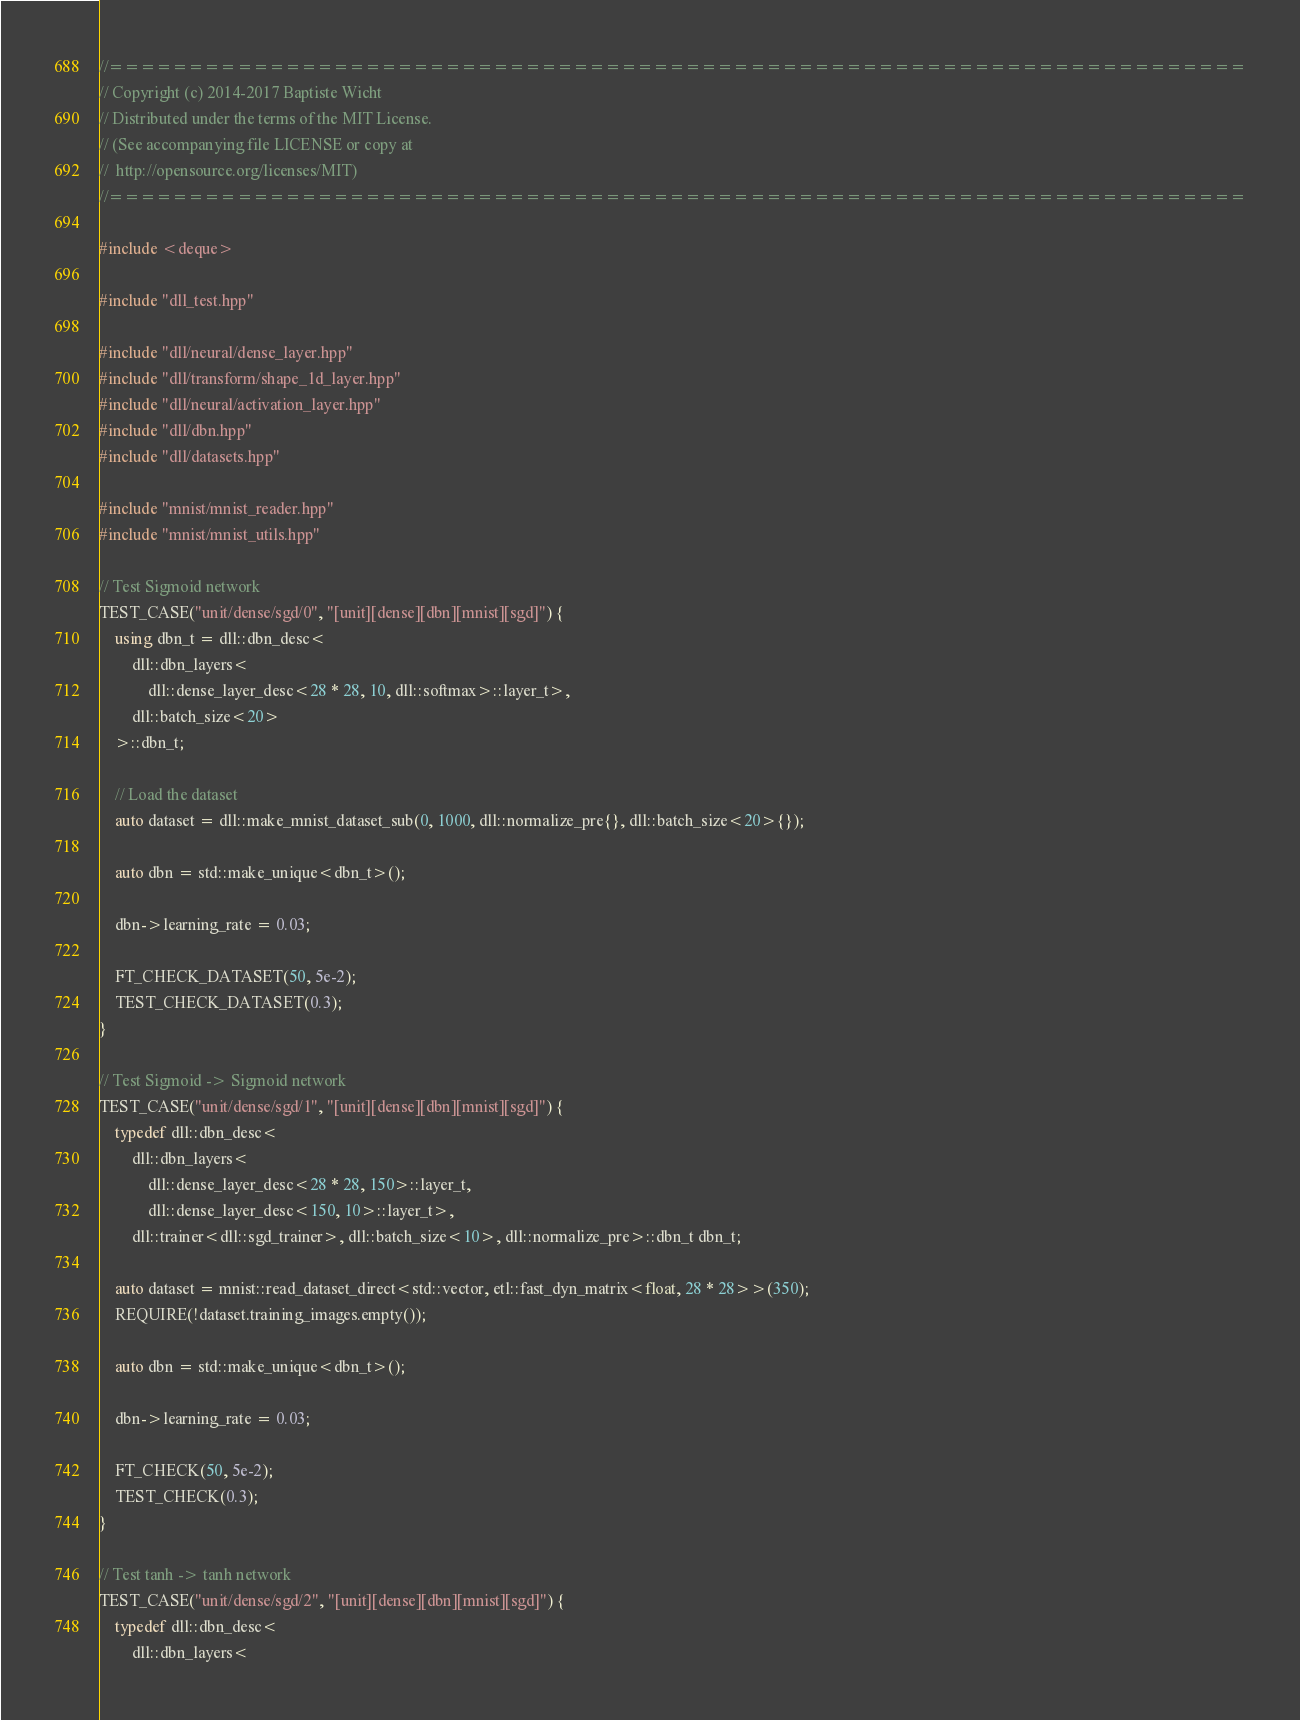<code> <loc_0><loc_0><loc_500><loc_500><_C++_>//=======================================================================
// Copyright (c) 2014-2017 Baptiste Wicht
// Distributed under the terms of the MIT License.
// (See accompanying file LICENSE or copy at
//  http://opensource.org/licenses/MIT)
//=======================================================================

#include <deque>

#include "dll_test.hpp"

#include "dll/neural/dense_layer.hpp"
#include "dll/transform/shape_1d_layer.hpp"
#include "dll/neural/activation_layer.hpp"
#include "dll/dbn.hpp"
#include "dll/datasets.hpp"

#include "mnist/mnist_reader.hpp"
#include "mnist/mnist_utils.hpp"

// Test Sigmoid network
TEST_CASE("unit/dense/sgd/0", "[unit][dense][dbn][mnist][sgd]") {
    using dbn_t = dll::dbn_desc<
        dll::dbn_layers<
            dll::dense_layer_desc<28 * 28, 10, dll::softmax>::layer_t>,
        dll::batch_size<20>
    >::dbn_t;

    // Load the dataset
    auto dataset = dll::make_mnist_dataset_sub(0, 1000, dll::normalize_pre{}, dll::batch_size<20>{});

    auto dbn = std::make_unique<dbn_t>();

    dbn->learning_rate = 0.03;

    FT_CHECK_DATASET(50, 5e-2);
    TEST_CHECK_DATASET(0.3);
}

// Test Sigmoid -> Sigmoid network
TEST_CASE("unit/dense/sgd/1", "[unit][dense][dbn][mnist][sgd]") {
    typedef dll::dbn_desc<
        dll::dbn_layers<
            dll::dense_layer_desc<28 * 28, 150>::layer_t,
            dll::dense_layer_desc<150, 10>::layer_t>,
        dll::trainer<dll::sgd_trainer>, dll::batch_size<10>, dll::normalize_pre>::dbn_t dbn_t;

    auto dataset = mnist::read_dataset_direct<std::vector, etl::fast_dyn_matrix<float, 28 * 28>>(350);
    REQUIRE(!dataset.training_images.empty());

    auto dbn = std::make_unique<dbn_t>();

    dbn->learning_rate = 0.03;

    FT_CHECK(50, 5e-2);
    TEST_CHECK(0.3);
}

// Test tanh -> tanh network
TEST_CASE("unit/dense/sgd/2", "[unit][dense][dbn][mnist][sgd]") {
    typedef dll::dbn_desc<
        dll::dbn_layers<</code> 